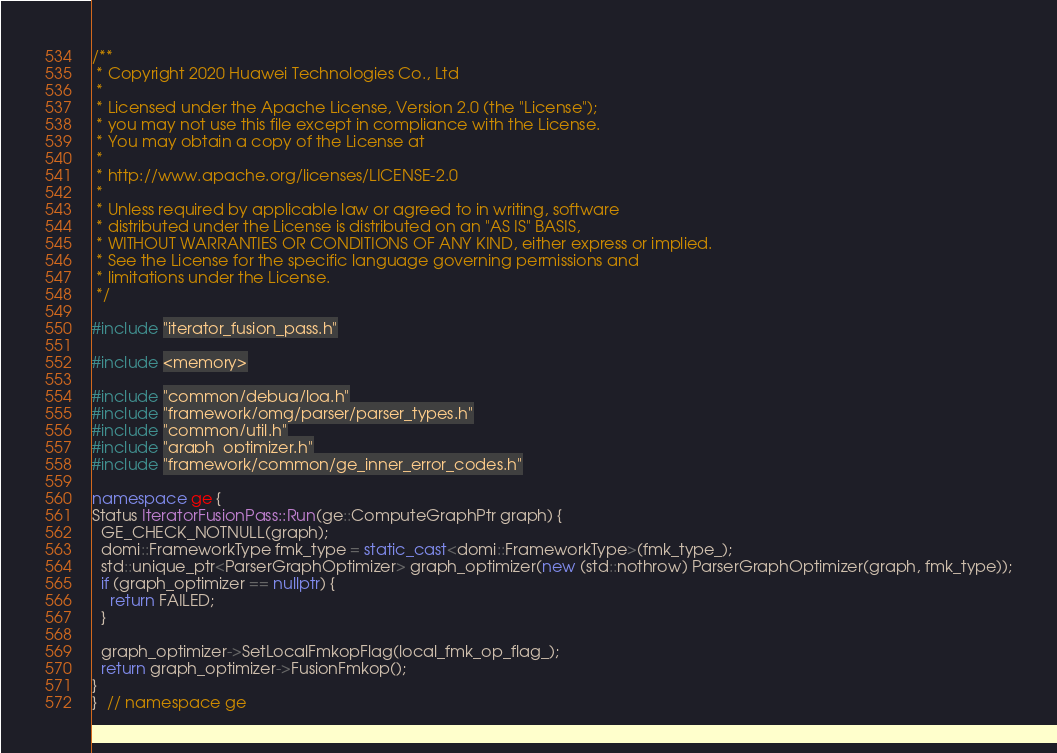Convert code to text. <code><loc_0><loc_0><loc_500><loc_500><_C++_>/**
 * Copyright 2020 Huawei Technologies Co., Ltd
 *
 * Licensed under the Apache License, Version 2.0 (the "License");
 * you may not use this file except in compliance with the License.
 * You may obtain a copy of the License at
 *
 * http://www.apache.org/licenses/LICENSE-2.0
 *
 * Unless required by applicable law or agreed to in writing, software
 * distributed under the License is distributed on an "AS IS" BASIS,
 * WITHOUT WARRANTIES OR CONDITIONS OF ANY KIND, either express or implied.
 * See the License for the specific language governing permissions and
 * limitations under the License.
 */

#include "iterator_fusion_pass.h"

#include <memory>

#include "common/debug/log.h"
#include "framework/omg/parser/parser_types.h"
#include "common/util.h"
#include "graph_optimizer.h"
#include "framework/common/ge_inner_error_codes.h"

namespace ge {
Status IteratorFusionPass::Run(ge::ComputeGraphPtr graph) {
  GE_CHECK_NOTNULL(graph);
  domi::FrameworkType fmk_type = static_cast<domi::FrameworkType>(fmk_type_);
  std::unique_ptr<ParserGraphOptimizer> graph_optimizer(new (std::nothrow) ParserGraphOptimizer(graph, fmk_type));
  if (graph_optimizer == nullptr) {
    return FAILED;
  }

  graph_optimizer->SetLocalFmkopFlag(local_fmk_op_flag_);
  return graph_optimizer->FusionFmkop();
}
}  // namespace ge
</code> 